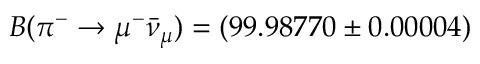<formula> <loc_0><loc_0><loc_500><loc_500>B ( \pi ^ { - } \to \mu ^ { - } \bar { \nu } _ { \mu } ) = ( 9 9 . 9 8 7 7 0 \pm 0 . 0 0 0 0 4 ) \</formula> 